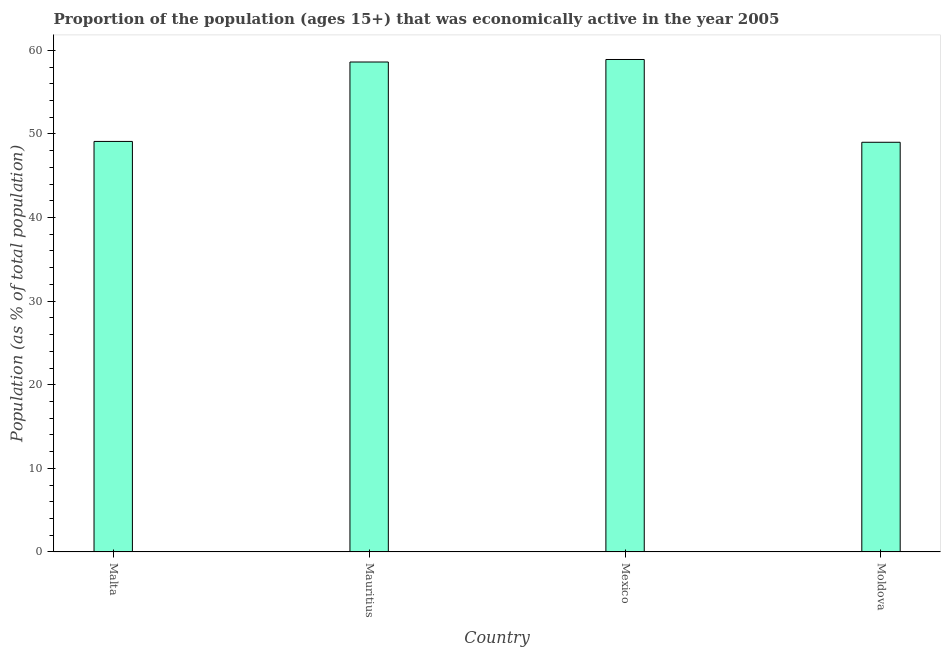Does the graph contain grids?
Ensure brevity in your answer.  No. What is the title of the graph?
Your answer should be very brief. Proportion of the population (ages 15+) that was economically active in the year 2005. What is the label or title of the X-axis?
Provide a short and direct response. Country. What is the label or title of the Y-axis?
Ensure brevity in your answer.  Population (as % of total population). What is the percentage of economically active population in Malta?
Ensure brevity in your answer.  49.1. Across all countries, what is the maximum percentage of economically active population?
Provide a succinct answer. 58.9. In which country was the percentage of economically active population minimum?
Your response must be concise. Moldova. What is the sum of the percentage of economically active population?
Keep it short and to the point. 215.6. What is the average percentage of economically active population per country?
Keep it short and to the point. 53.9. What is the median percentage of economically active population?
Give a very brief answer. 53.85. In how many countries, is the percentage of economically active population greater than 4 %?
Your answer should be compact. 4. What is the ratio of the percentage of economically active population in Malta to that in Mauritius?
Offer a very short reply. 0.84. Is the percentage of economically active population in Mexico less than that in Moldova?
Your answer should be compact. No. What is the difference between the highest and the second highest percentage of economically active population?
Your answer should be very brief. 0.3. Is the sum of the percentage of economically active population in Mexico and Moldova greater than the maximum percentage of economically active population across all countries?
Provide a short and direct response. Yes. What is the difference between the highest and the lowest percentage of economically active population?
Ensure brevity in your answer.  9.9. Are the values on the major ticks of Y-axis written in scientific E-notation?
Offer a very short reply. No. What is the Population (as % of total population) of Malta?
Your response must be concise. 49.1. What is the Population (as % of total population) in Mauritius?
Your answer should be compact. 58.6. What is the Population (as % of total population) in Mexico?
Your answer should be compact. 58.9. What is the difference between the Population (as % of total population) in Malta and Mauritius?
Give a very brief answer. -9.5. What is the difference between the Population (as % of total population) in Malta and Mexico?
Keep it short and to the point. -9.8. What is the difference between the Population (as % of total population) in Malta and Moldova?
Ensure brevity in your answer.  0.1. What is the difference between the Population (as % of total population) in Mauritius and Mexico?
Provide a short and direct response. -0.3. What is the ratio of the Population (as % of total population) in Malta to that in Mauritius?
Offer a very short reply. 0.84. What is the ratio of the Population (as % of total population) in Malta to that in Mexico?
Offer a very short reply. 0.83. What is the ratio of the Population (as % of total population) in Mauritius to that in Moldova?
Give a very brief answer. 1.2. What is the ratio of the Population (as % of total population) in Mexico to that in Moldova?
Ensure brevity in your answer.  1.2. 